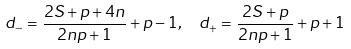<formula> <loc_0><loc_0><loc_500><loc_500>d _ { - } = \frac { 2 S + p + 4 n } { 2 n p + 1 } + p - 1 , \ \ d _ { + } = \frac { 2 S + p } { 2 n p + 1 } + p + 1</formula> 